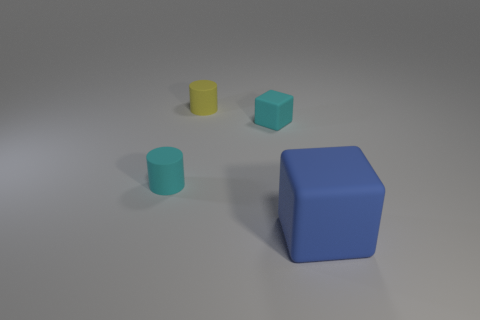There is a cyan cylinder; what number of tiny matte things are in front of it?
Keep it short and to the point. 0. Is there a ball of the same size as the cyan cylinder?
Your answer should be compact. No. Does the cylinder that is on the left side of the yellow object have the same size as the rubber block on the left side of the large matte block?
Ensure brevity in your answer.  Yes. Are there any small objects that have the same shape as the big thing?
Give a very brief answer. Yes. Are there the same number of cyan rubber blocks behind the small cyan block and big yellow matte objects?
Make the answer very short. Yes. Do the yellow rubber object and the cube on the right side of the tiny rubber cube have the same size?
Your answer should be compact. No. What number of yellow cubes have the same material as the small yellow thing?
Your answer should be compact. 0. Does the blue block have the same size as the yellow cylinder?
Your response must be concise. No. Is there anything else that is the same color as the big object?
Your response must be concise. No. What is the shape of the object that is to the left of the blue rubber block and right of the yellow cylinder?
Provide a succinct answer. Cube. 